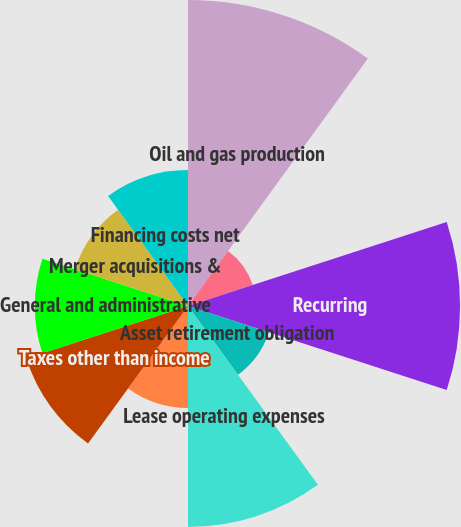<chart> <loc_0><loc_0><loc_500><loc_500><pie_chart><fcel>Oil and gas production<fcel>Other<fcel>Recurring<fcel>Asset retirement obligation<fcel>Lease operating expenses<fcel>Gathering and transportation<fcel>Taxes other than income<fcel>General and administrative<fcel>Merger acquisitions &<fcel>Financing costs net<nl><fcel>18.75%<fcel>4.17%<fcel>16.67%<fcel>5.21%<fcel>13.54%<fcel>6.25%<fcel>10.42%<fcel>9.38%<fcel>7.29%<fcel>8.33%<nl></chart> 